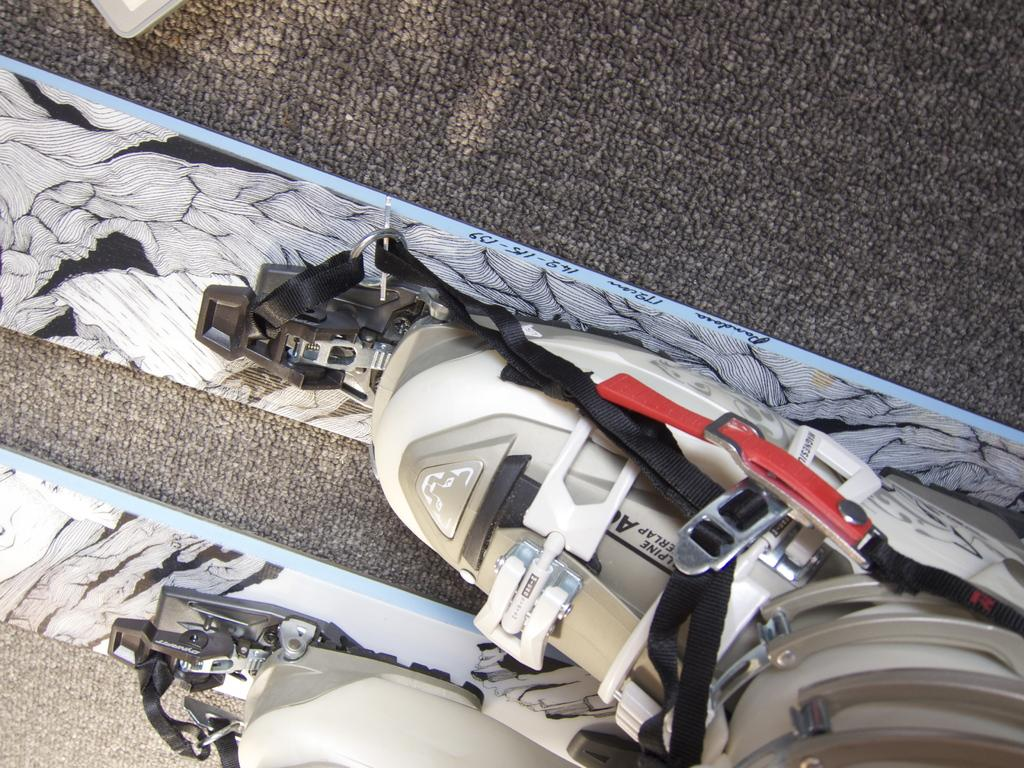What is placed on the mat in the image? There are keys on a mat in the image. Can you describe the object at the top of the image? Unfortunately, the provided facts do not give any information about the object at the top of the image. How many patches are visible on the volleyball in the image? There is no volleyball present in the image, so there are no patches to count. 